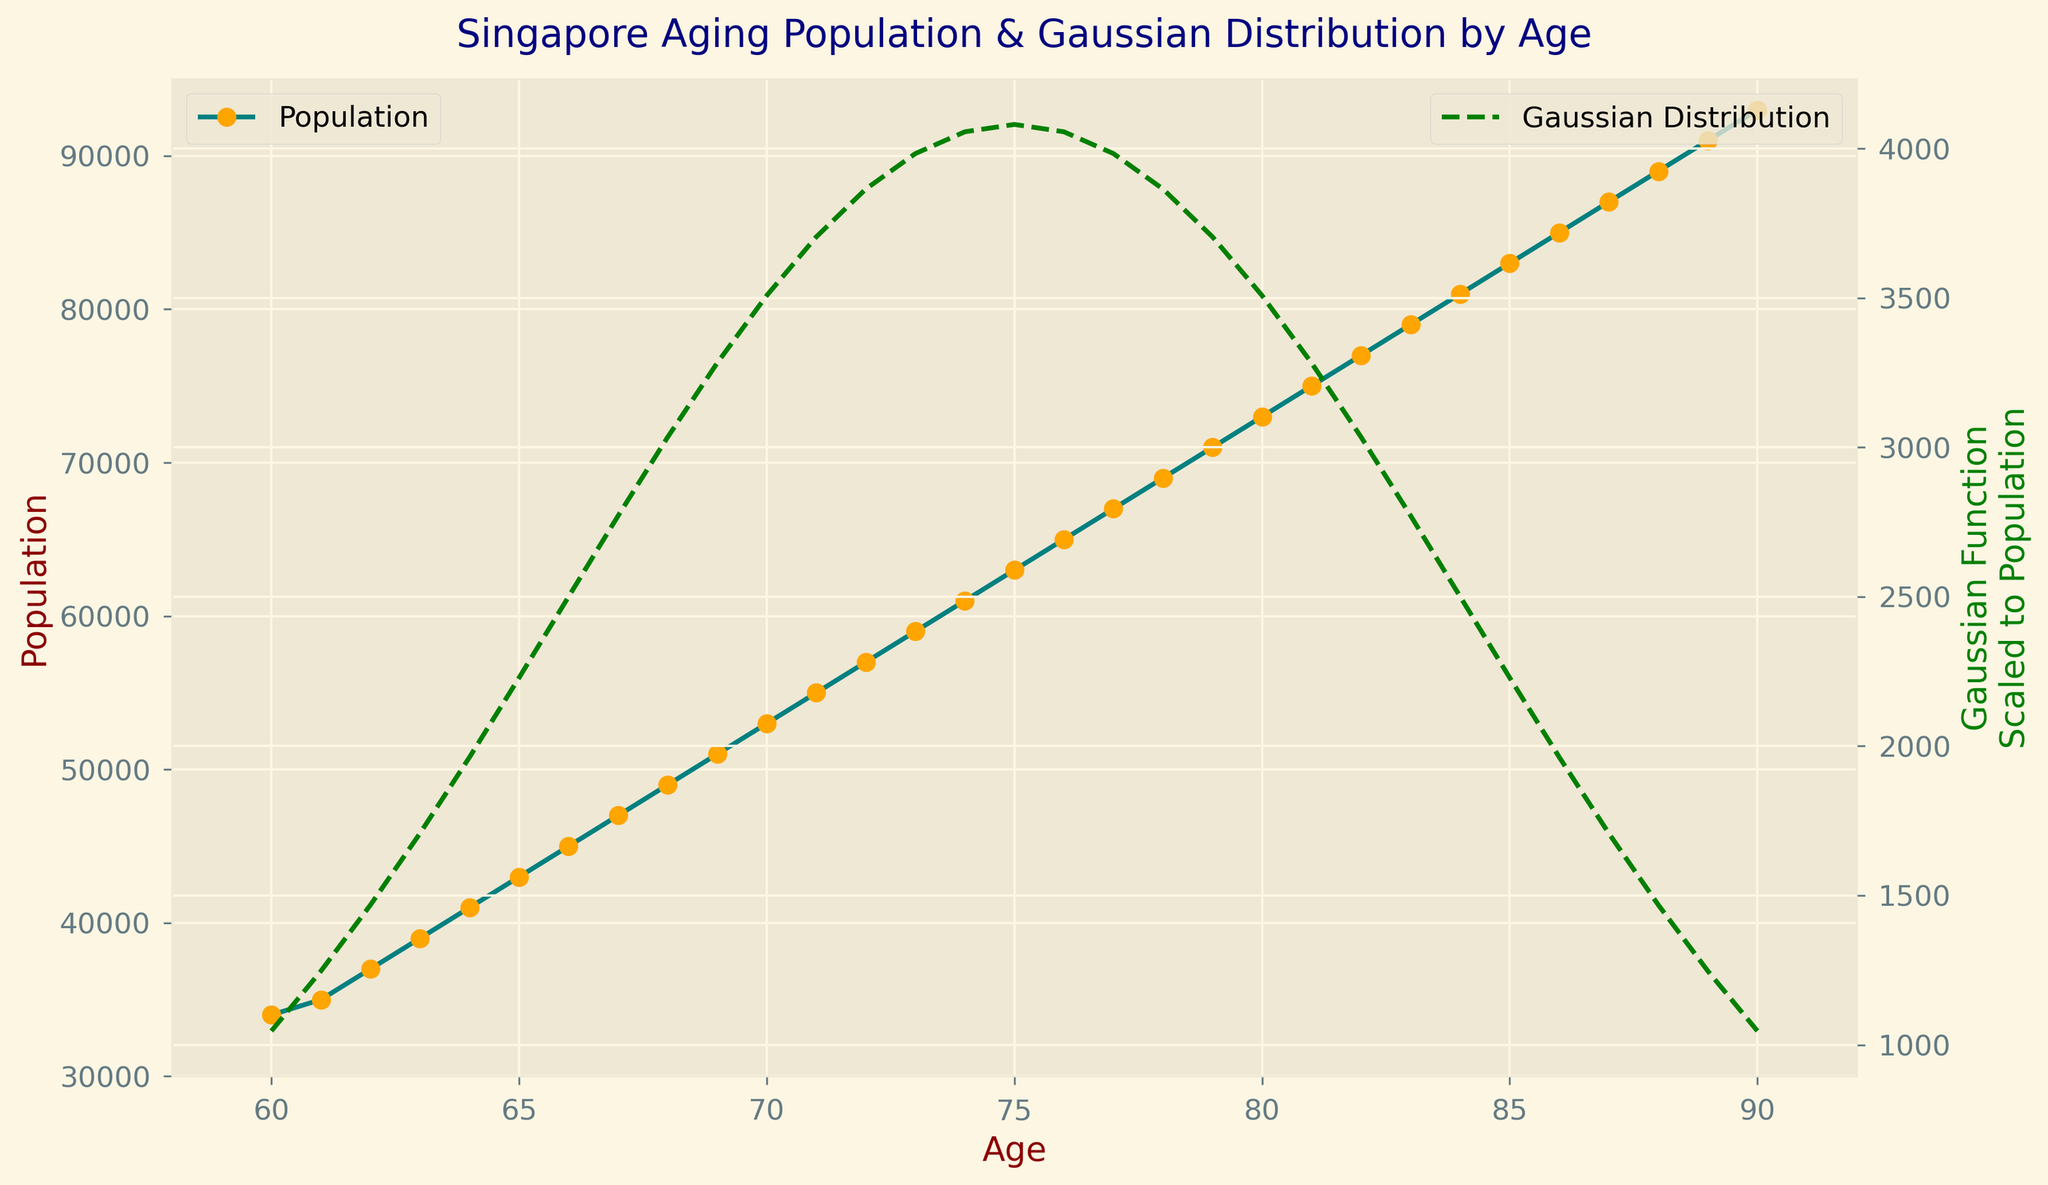What is the population of the 70-year-old age group? Refer to the plot and locate the age group corresponding to 70 years old. The population for that group is marked at the point where age is 70.
Answer: 53,000 Which age group has the highest population? Identify the peak point on the population plot. The age corresponding to the highest point represents the age group with the highest population. The peak is at age 90.
Answer: 90 years old What is the range of ages covered in the plot? Check the x-axis to determine the starting and ending points. The first age shown is 60, and the last age is 90.
Answer: 60 to 90 years old What is the mean age of the given population data? Calculate the average of the ages by summing the ages from 60 to 90 and dividing by the number of data points (31). The mean age can also be inferred from the figure title, mentioning the Gaussian function with the mean.
Answer: 75 years old How does the Gaussian function help interpret the population data? The Gaussian function highlights the central tendency and spread of the age distribution, helping to contextualize the concentration of the aging population around the mean age.
Answer: Highlights the central tendency Is the Gaussian function line higher or lower than the population line for most age groups? Check the plot to see the relative positions of the Gaussian function line (green dashed line) and the population line (teal line). The green dashed line is generally below the actual population data, indicating the Gaussian curve's theoretical prediction is lower.
Answer: Lower Which age segments show an increasing trend in population? Observe the population line. Each age group from 60 to 90 shows an increase, implying an increasing trend throughout the data range.
Answer: Ages 60 to 90 For which age is the population approximately equal to 75,000? Find the point where the population value (teal line) is closest to 75,000. This occurs at age 81.
Answer: 81 years old 